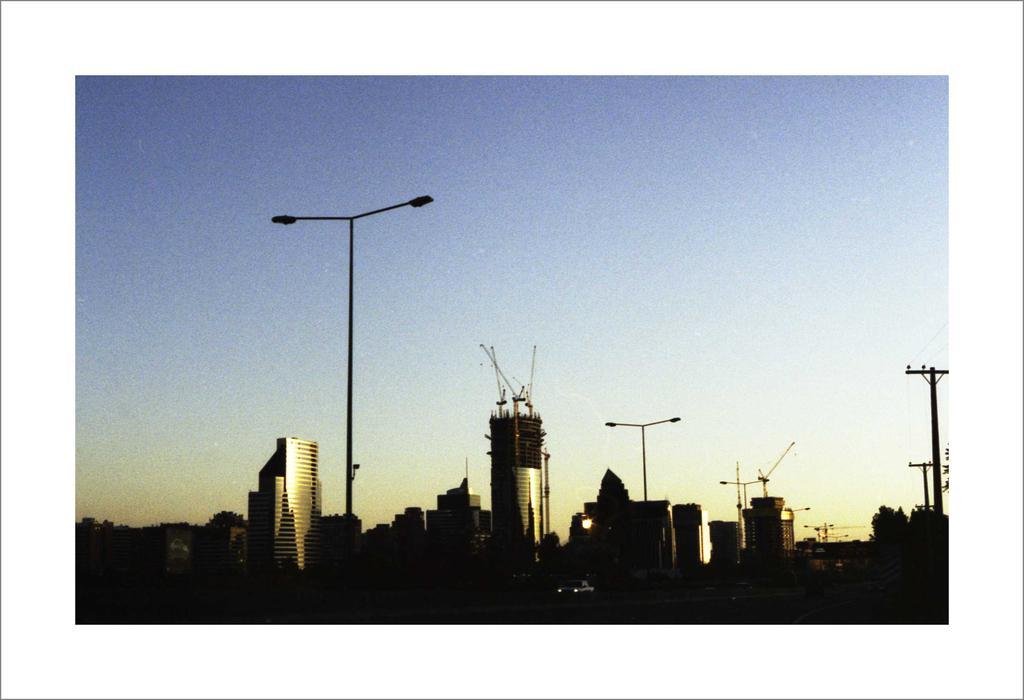Please provide a concise description of this image. There are few buildings and poles and the sky is blue in color. 